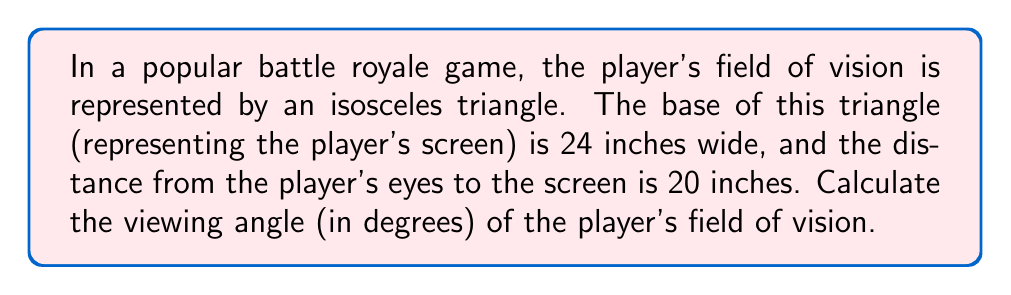Give your solution to this math problem. To solve this problem, we'll use trigonometry. Let's break it down step-by-step:

1) The player's field of vision forms an isosceles triangle. The base of this triangle is the width of the screen, and the height is the distance from the player's eyes to the screen.

2) We can split this isosceles triangle into two right triangles. Let's focus on one of these right triangles.

3) In this right triangle:
   - The base is half the screen width: $12$ inches (24/2)
   - The height is the distance to the screen: $20$ inches

4) We want to find the angle at the apex of the isosceles triangle. This angle is twice the angle in our right triangle.

5) In the right triangle, we can use the tangent function:

   $$\tan(\theta) = \frac{\text{opposite}}{\text{adjacent}} = \frac{12}{20} = 0.6$$

6) To find $\theta$, we use the inverse tangent (arctangent) function:

   $$\theta = \arctan(0.6) \approx 30.96^\circ$$

7) Remember, this is only half of our viewing angle. The full viewing angle is twice this:

   $$\text{Viewing Angle} = 2 \theta \approx 2 * 30.96^\circ = 61.93^\circ$$

[asy]
import geometry;

pair A = (0,0), B = (12,0), C = (0,20);
draw(A--B--C--A);
draw((-12,0)--(12,0));
draw((0,20)--(-12,0));

label("24\"", (0,-1), S);
label("20\"", (-1,10), W);
label("θ", (1,1), NE);
label("θ", (-1,1), NW);

dot("Player's eyes", (0,20), N);
[/asy]
Answer: The viewing angle of the player's field of vision is approximately $61.93^\circ$. 